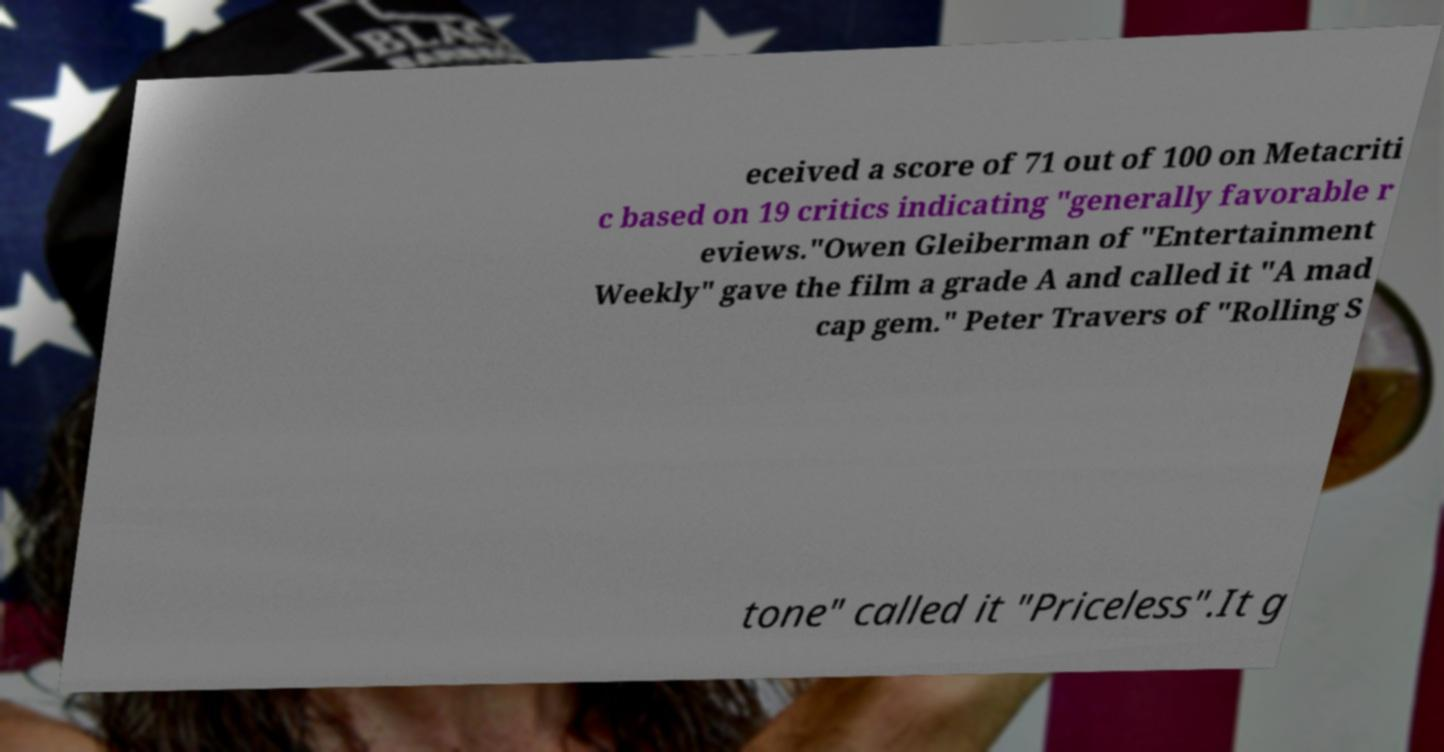Could you assist in decoding the text presented in this image and type it out clearly? eceived a score of 71 out of 100 on Metacriti c based on 19 critics indicating "generally favorable r eviews."Owen Gleiberman of "Entertainment Weekly" gave the film a grade A and called it "A mad cap gem." Peter Travers of "Rolling S tone" called it "Priceless".It g 